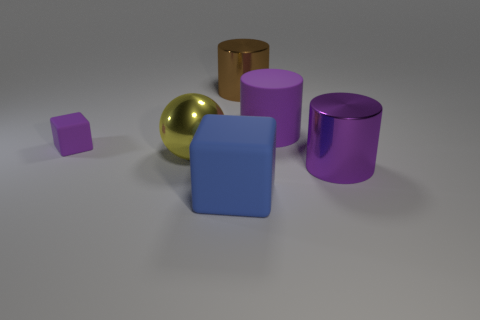Is there any other thing that has the same size as the purple matte block?
Your response must be concise. No. Is the number of big yellow shiny things in front of the large purple metal cylinder greater than the number of big brown metallic cylinders?
Offer a terse response. No. There is a big purple object in front of the big yellow thing; what is it made of?
Your answer should be very brief. Metal. What number of other objects have the same material as the blue thing?
Provide a succinct answer. 2. There is a thing that is behind the big shiny ball and to the left of the blue matte thing; what is its shape?
Ensure brevity in your answer.  Cube. What number of objects are large cylinders behind the yellow shiny sphere or purple matte objects that are to the right of the big yellow thing?
Ensure brevity in your answer.  2. Is the number of large spheres that are behind the brown object the same as the number of blue objects right of the large purple matte thing?
Offer a very short reply. Yes. The purple object in front of the yellow thing in front of the brown object is what shape?
Keep it short and to the point. Cylinder. Are there any other large metal objects of the same shape as the big blue object?
Your response must be concise. No. What number of green metal cubes are there?
Ensure brevity in your answer.  0. 